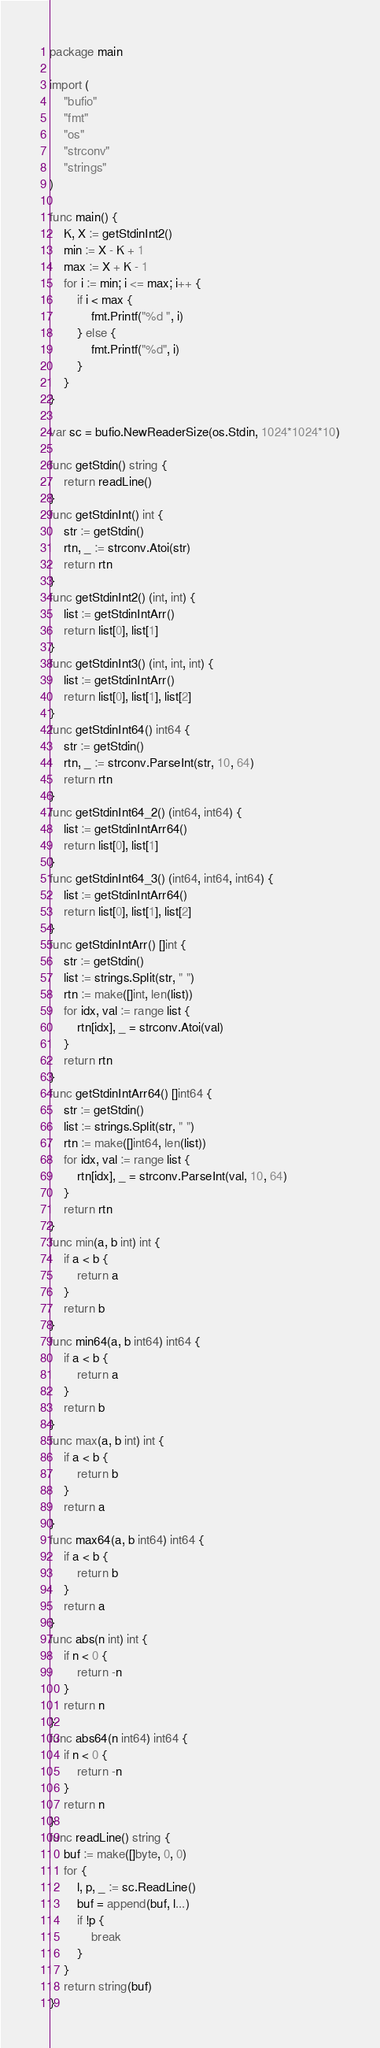Convert code to text. <code><loc_0><loc_0><loc_500><loc_500><_Go_>package main

import (
	"bufio"
	"fmt"
	"os"
	"strconv"
	"strings"
)

func main() {
	K, X := getStdinInt2()
	min := X - K + 1
	max := X + K - 1
	for i := min; i <= max; i++ {
		if i < max {
			fmt.Printf("%d ", i)
		} else {
			fmt.Printf("%d", i)
		}
	}
}

var sc = bufio.NewReaderSize(os.Stdin, 1024*1024*10)

func getStdin() string {
	return readLine()
}
func getStdinInt() int {
	str := getStdin()
	rtn, _ := strconv.Atoi(str)
	return rtn
}
func getStdinInt2() (int, int) {
	list := getStdinIntArr()
	return list[0], list[1]
}
func getStdinInt3() (int, int, int) {
	list := getStdinIntArr()
	return list[0], list[1], list[2]
}
func getStdinInt64() int64 {
	str := getStdin()
	rtn, _ := strconv.ParseInt(str, 10, 64)
	return rtn
}
func getStdinInt64_2() (int64, int64) {
	list := getStdinIntArr64()
	return list[0], list[1]
}
func getStdinInt64_3() (int64, int64, int64) {
	list := getStdinIntArr64()
	return list[0], list[1], list[2]
}
func getStdinIntArr() []int {
	str := getStdin()
	list := strings.Split(str, " ")
	rtn := make([]int, len(list))
	for idx, val := range list {
		rtn[idx], _ = strconv.Atoi(val)
	}
	return rtn
}
func getStdinIntArr64() []int64 {
	str := getStdin()
	list := strings.Split(str, " ")
	rtn := make([]int64, len(list))
	for idx, val := range list {
		rtn[idx], _ = strconv.ParseInt(val, 10, 64)
	}
	return rtn
}
func min(a, b int) int {
	if a < b {
		return a
	}
	return b
}
func min64(a, b int64) int64 {
	if a < b {
		return a
	}
	return b
}
func max(a, b int) int {
	if a < b {
		return b
	}
	return a
}
func max64(a, b int64) int64 {
	if a < b {
		return b
	}
	return a
}
func abs(n int) int {
	if n < 0 {
		return -n
	}
	return n
}
func abs64(n int64) int64 {
	if n < 0 {
		return -n
	}
	return n
}
func readLine() string {
	buf := make([]byte, 0, 0)
	for {
		l, p, _ := sc.ReadLine()
		buf = append(buf, l...)
		if !p {
			break
		}
	}
	return string(buf)
}
</code> 